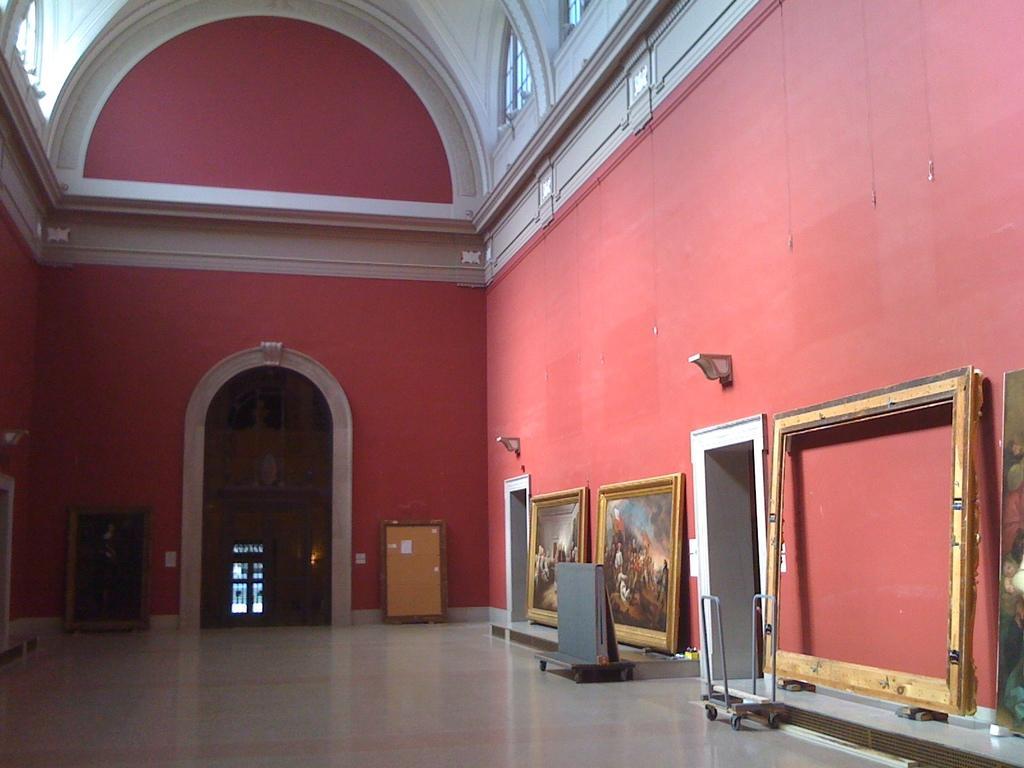Can you describe this image briefly? In the picture there is a room, there are many frames present, there are doors present. 